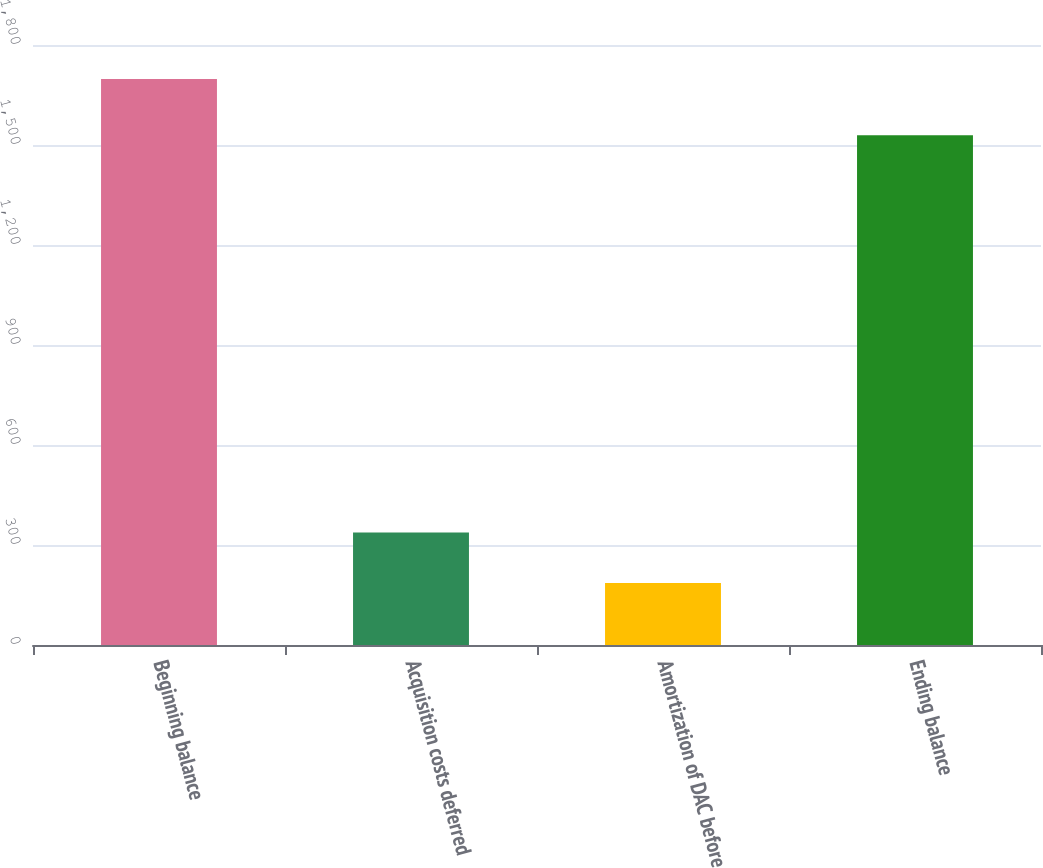Convert chart to OTSL. <chart><loc_0><loc_0><loc_500><loc_500><bar_chart><fcel>Beginning balance<fcel>Acquisition costs deferred<fcel>Amortization of DAC before<fcel>Ending balance<nl><fcel>1698<fcel>337.2<fcel>186<fcel>1529<nl></chart> 